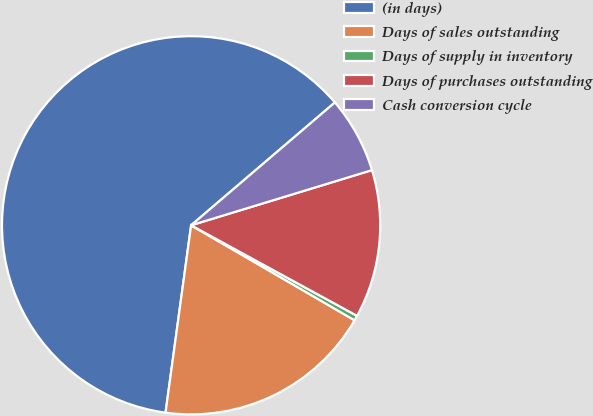<chart> <loc_0><loc_0><loc_500><loc_500><pie_chart><fcel>(in days)<fcel>Days of sales outstanding<fcel>Days of supply in inventory<fcel>Days of purchases outstanding<fcel>Cash conversion cycle<nl><fcel>61.59%<fcel>18.78%<fcel>0.43%<fcel>12.66%<fcel>6.54%<nl></chart> 